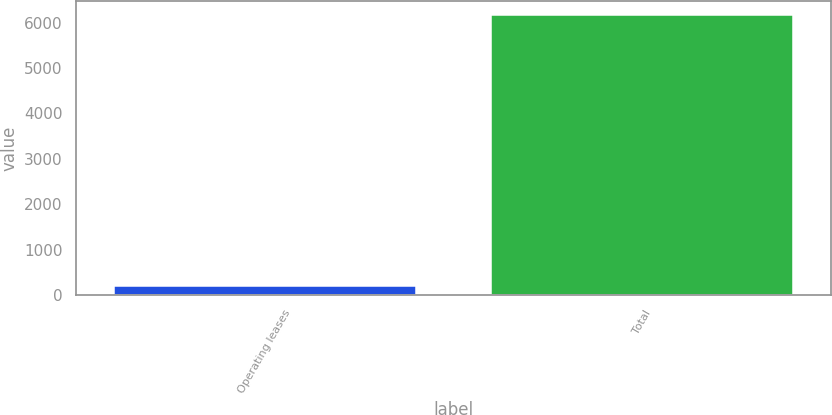Convert chart. <chart><loc_0><loc_0><loc_500><loc_500><bar_chart><fcel>Operating leases<fcel>Total<nl><fcel>199<fcel>6171<nl></chart> 